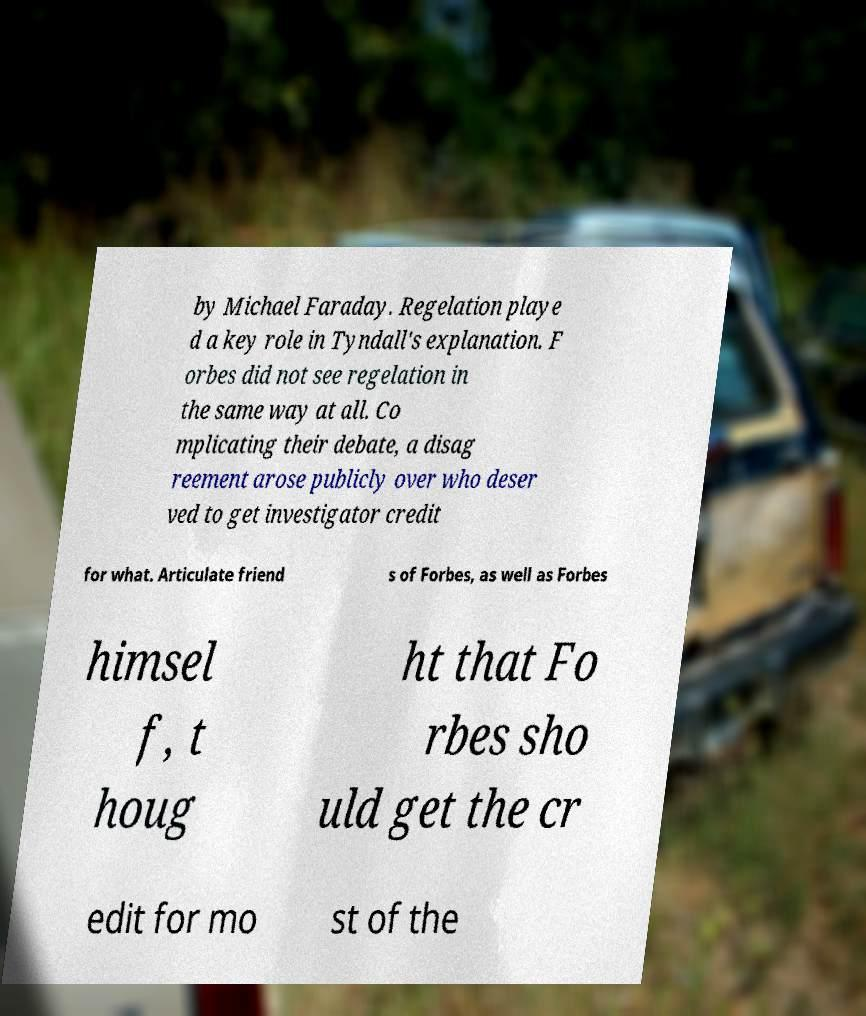Could you assist in decoding the text presented in this image and type it out clearly? by Michael Faraday. Regelation playe d a key role in Tyndall's explanation. F orbes did not see regelation in the same way at all. Co mplicating their debate, a disag reement arose publicly over who deser ved to get investigator credit for what. Articulate friend s of Forbes, as well as Forbes himsel f, t houg ht that Fo rbes sho uld get the cr edit for mo st of the 